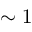<formula> <loc_0><loc_0><loc_500><loc_500>\sim 1</formula> 